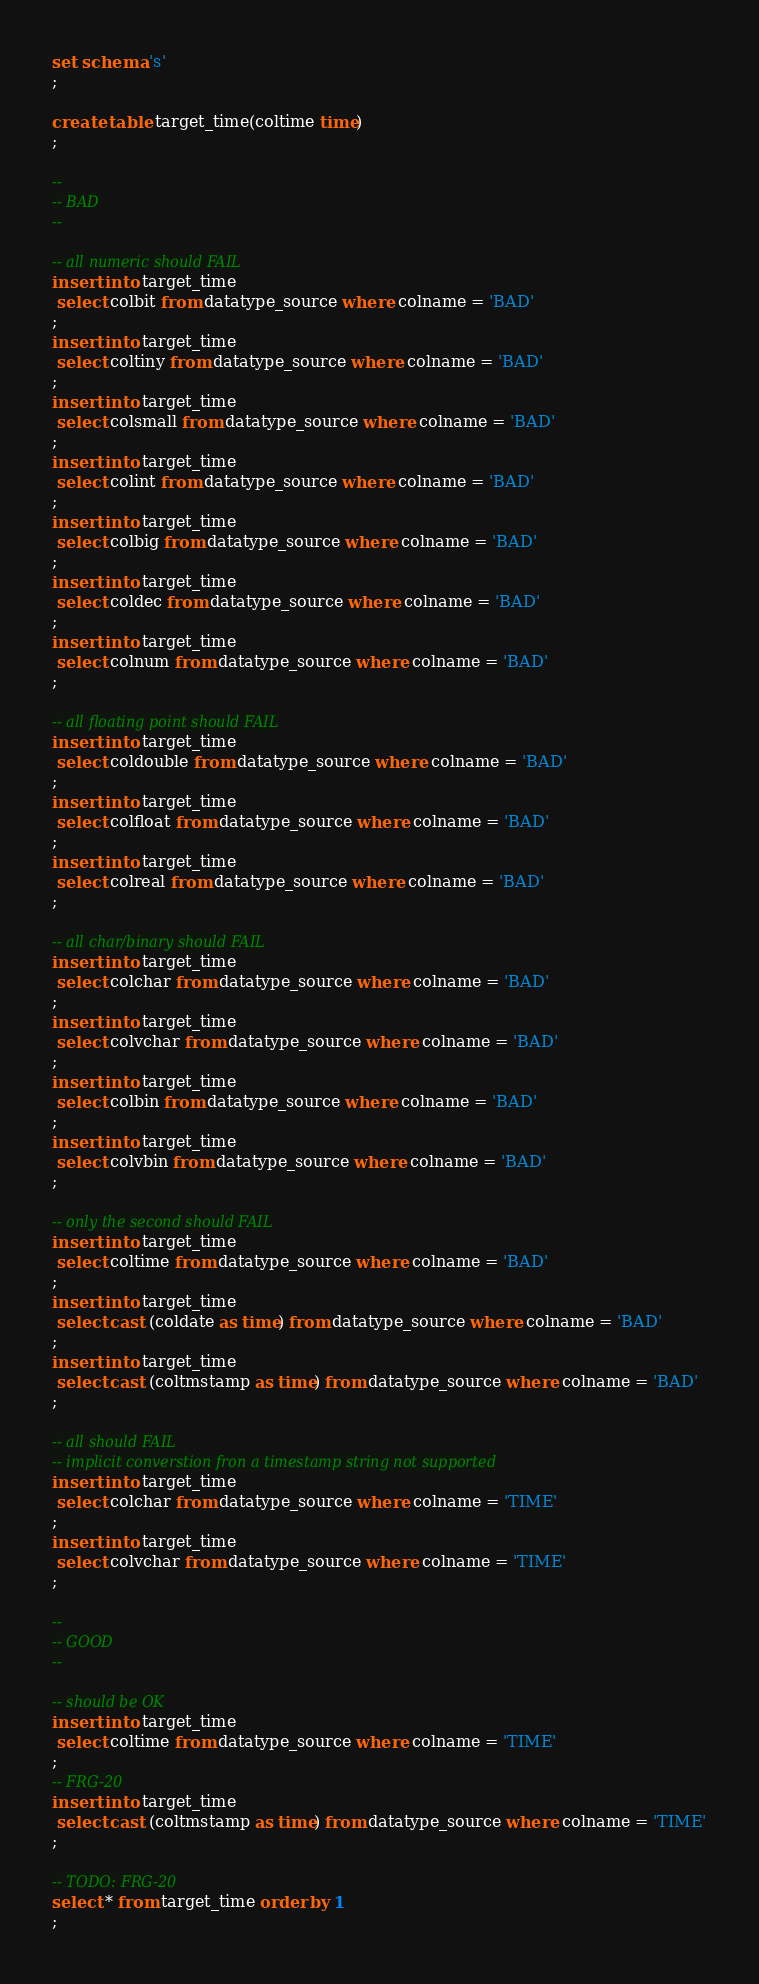Convert code to text. <code><loc_0><loc_0><loc_500><loc_500><_SQL_>set schema 's'
;

create table target_time(coltime time)
;

--
-- BAD
--

-- all numeric should FAIL
insert into target_time
 select colbit from datatype_source where colname = 'BAD'
;
insert into target_time
 select coltiny from datatype_source where colname = 'BAD'
;
insert into target_time
 select colsmall from datatype_source where colname = 'BAD'
;
insert into target_time
 select colint from datatype_source where colname = 'BAD'
;
insert into target_time
 select colbig from datatype_source where colname = 'BAD'
;
insert into target_time
 select coldec from datatype_source where colname = 'BAD'
;
insert into target_time
 select colnum from datatype_source where colname = 'BAD'
;

-- all floating point should FAIL
insert into target_time
 select coldouble from datatype_source where colname = 'BAD'
;
insert into target_time
 select colfloat from datatype_source where colname = 'BAD'
;
insert into target_time
 select colreal from datatype_source where colname = 'BAD'
;

-- all char/binary should FAIL
insert into target_time
 select colchar from datatype_source where colname = 'BAD'
;
insert into target_time
 select colvchar from datatype_source where colname = 'BAD'
;
insert into target_time
 select colbin from datatype_source where colname = 'BAD'
;
insert into target_time
 select colvbin from datatype_source where colname = 'BAD'
;

-- only the second should FAIL
insert into target_time
 select coltime from datatype_source where colname = 'BAD'
;
insert into target_time
 select cast (coldate as time) from datatype_source where colname = 'BAD'
;
insert into target_time
 select cast (coltmstamp as time) from datatype_source where colname = 'BAD'
;

-- all should FAIL
-- implicit converstion fron a timestamp string not supported
insert into target_time
 select colchar from datatype_source where colname = 'TIME'
;
insert into target_time
 select colvchar from datatype_source where colname = 'TIME'
;

--
-- GOOD
--

-- should be OK
insert into target_time
 select coltime from datatype_source where colname = 'TIME'
;
-- FRG-20
insert into target_time
 select cast (coltmstamp as time) from datatype_source where colname = 'TIME'
;

-- TODO: FRG-20
select * from target_time order by 1
;
</code> 